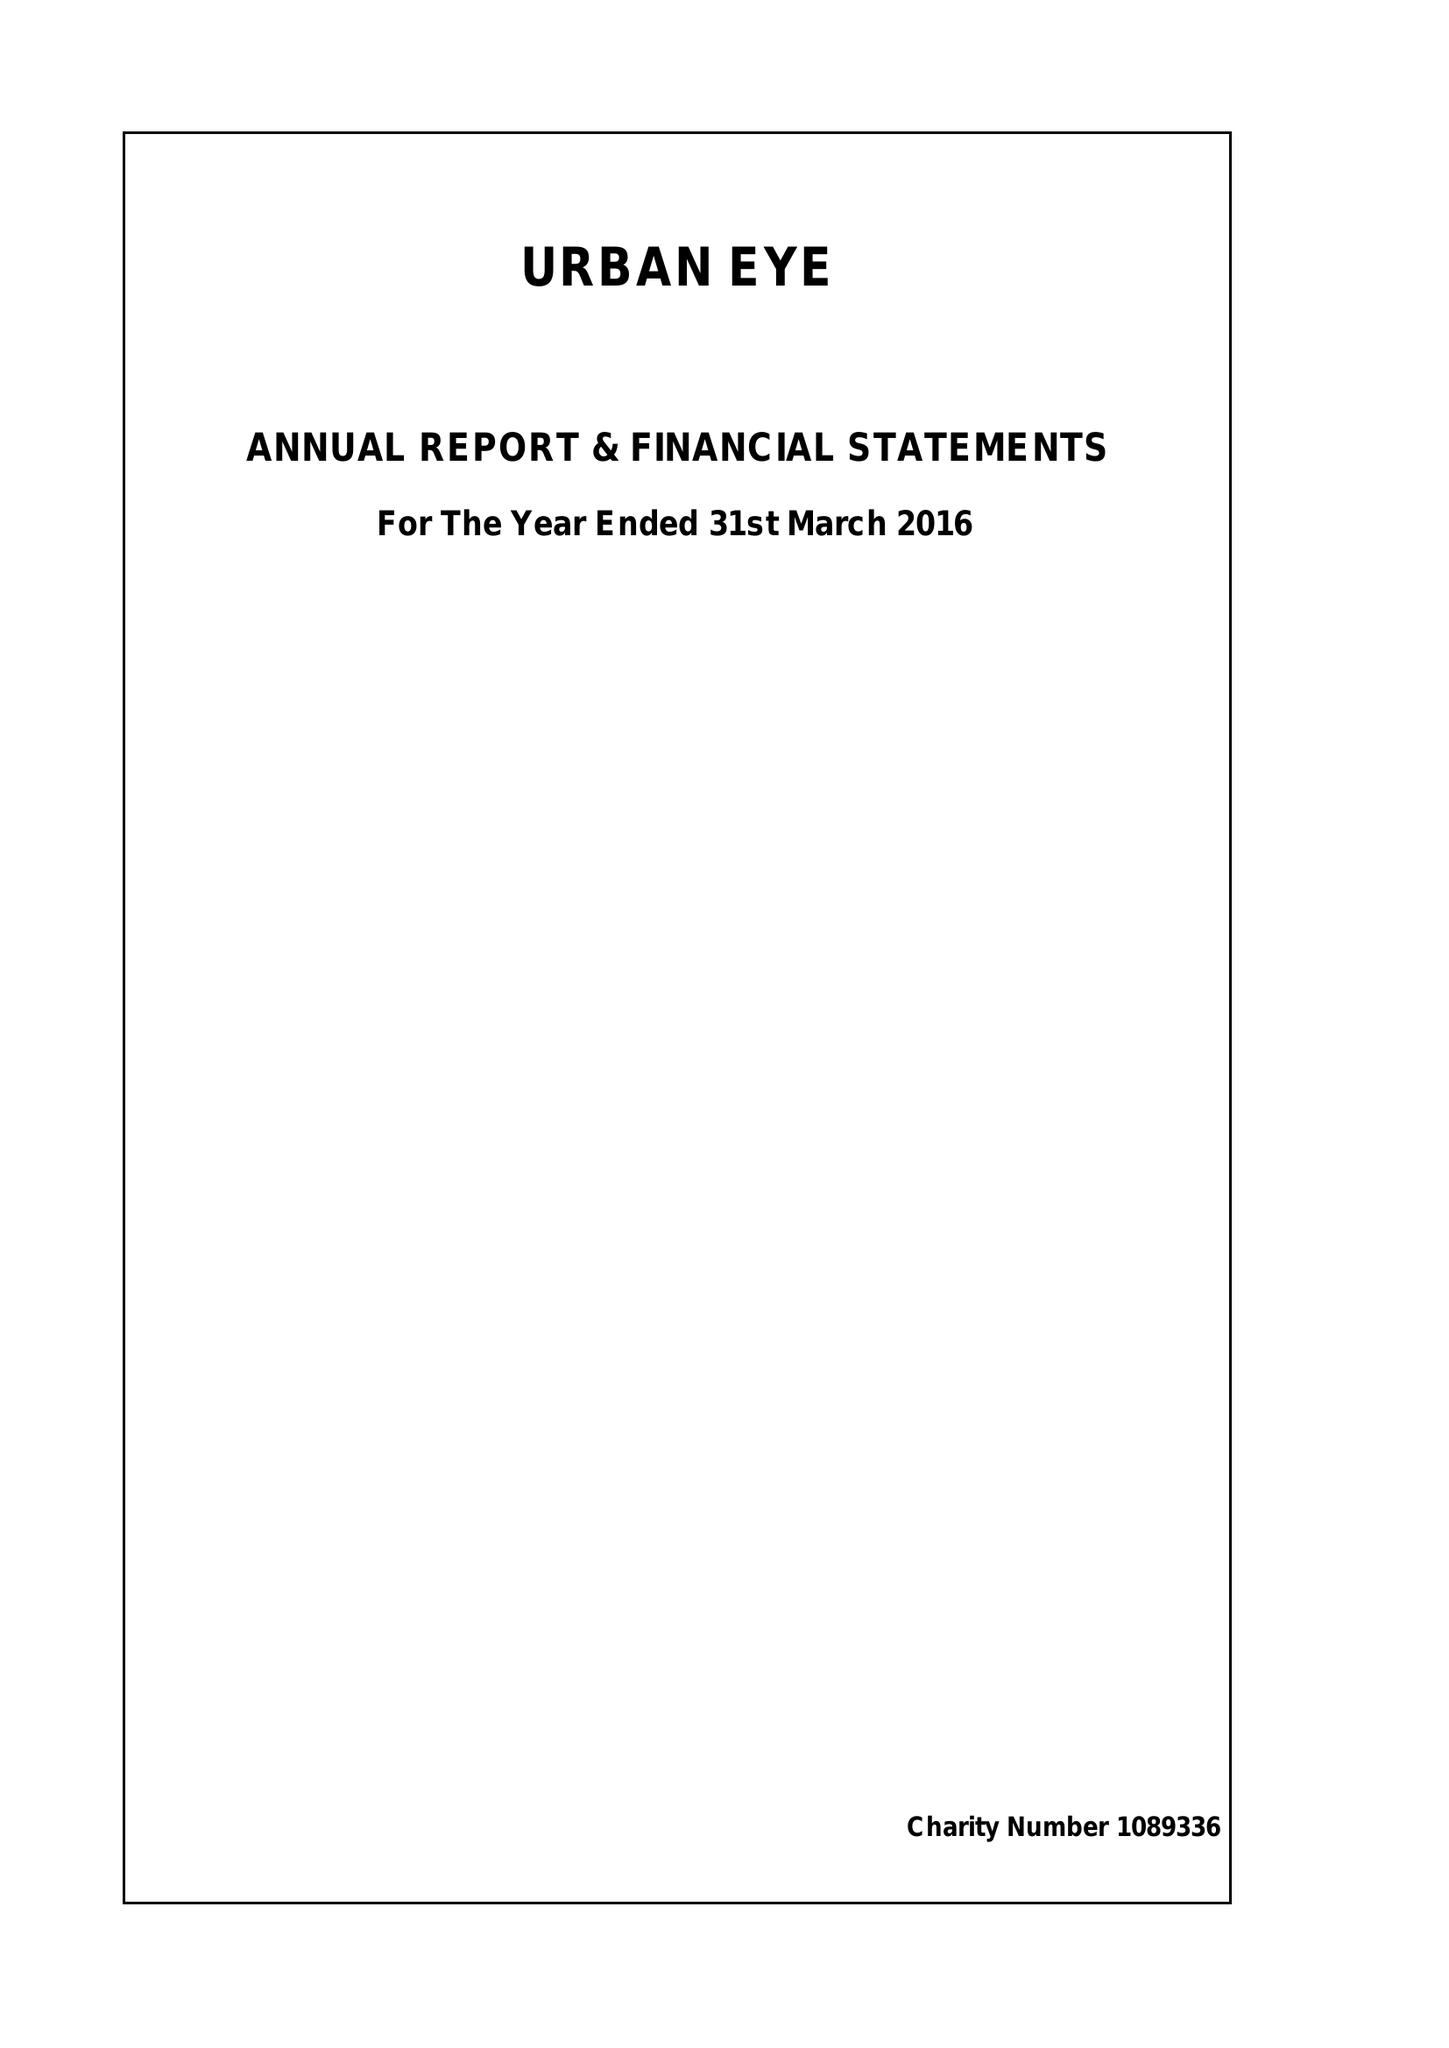What is the value for the address__post_town?
Answer the question using a single word or phrase. LONDON 